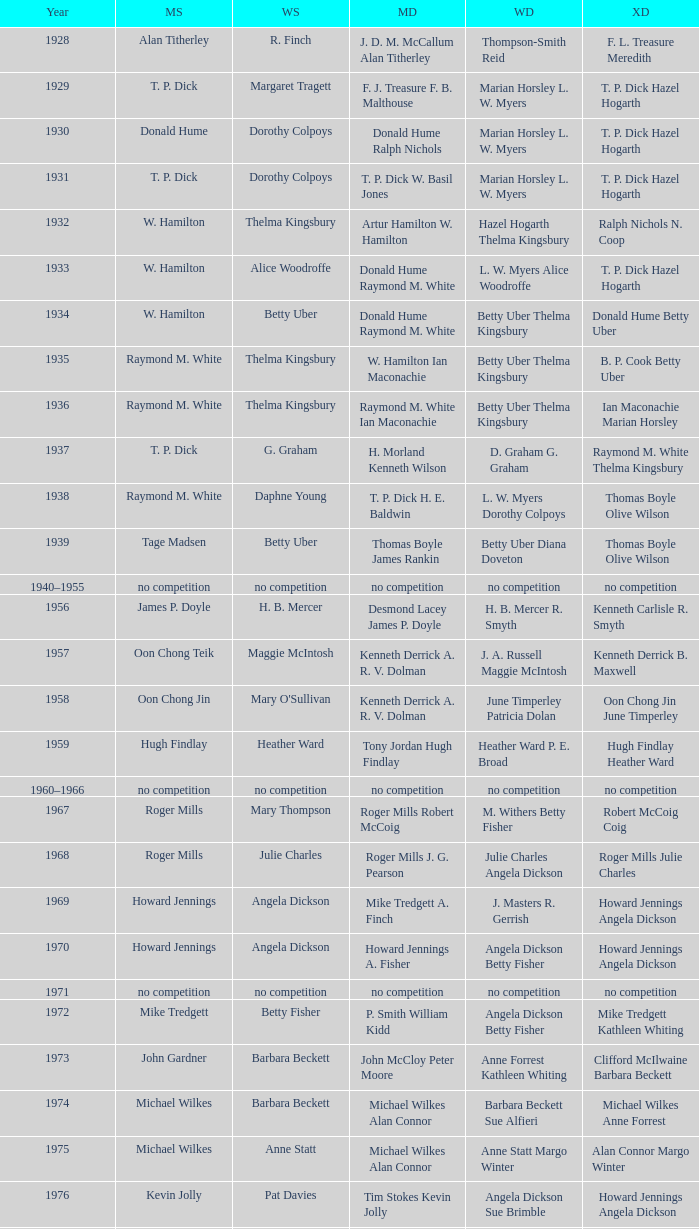Who claimed victory in the women's singles, in the same year that raymond m. white achieved success in the men's singles and w. hamilton ian maconachie conquered the men's doubles? Thelma Kingsbury. 